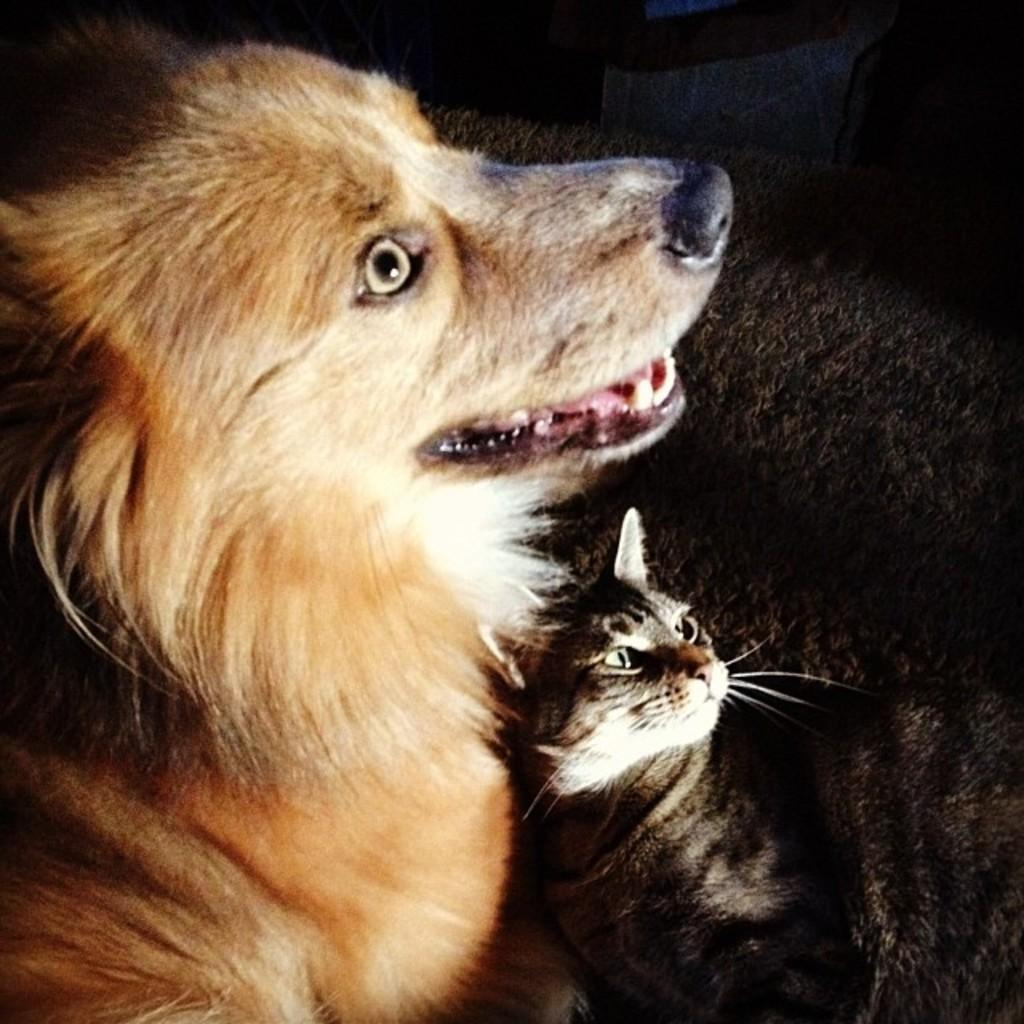What type of animals can be seen on the ground in the image? The facts do not specify the type of animals, so we cannot determine the specific animals present. What can be observed about the background of the image? The background of the image is dark. How many babies are present in the image? There is no mention of babies in the image, so we cannot determine the number of babies present. Is there a judge presiding over a fight in the image? There is no mention of a judge or a fight in the image, so we cannot determine if such an event is taking place. 